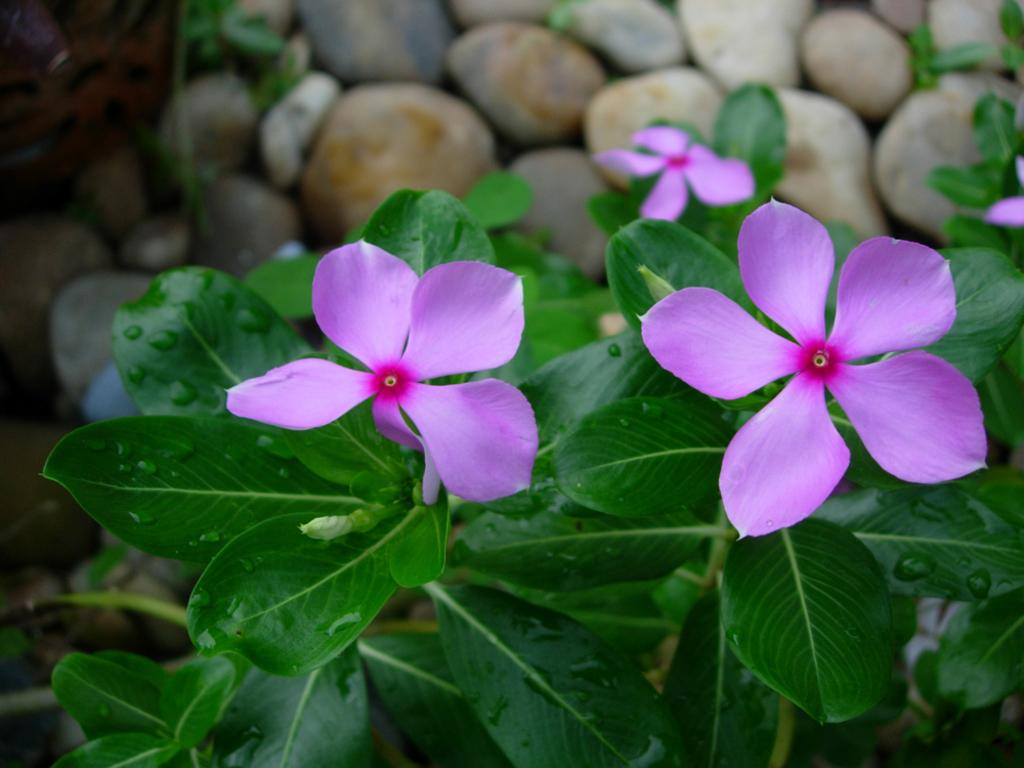What is the primary feature of the landscape in the image? There are many rocks in the image. Are there any living organisms visible in the image? Yes, there are few plants in the image. What type of flowers can be seen on the plants? There are flowers on the plants in the image. What type of umbrella is being used by the monkey in the image? There is no monkey or umbrella present in the image. How is the hammer being used by the plants in the image? There is no hammer present in the image. 